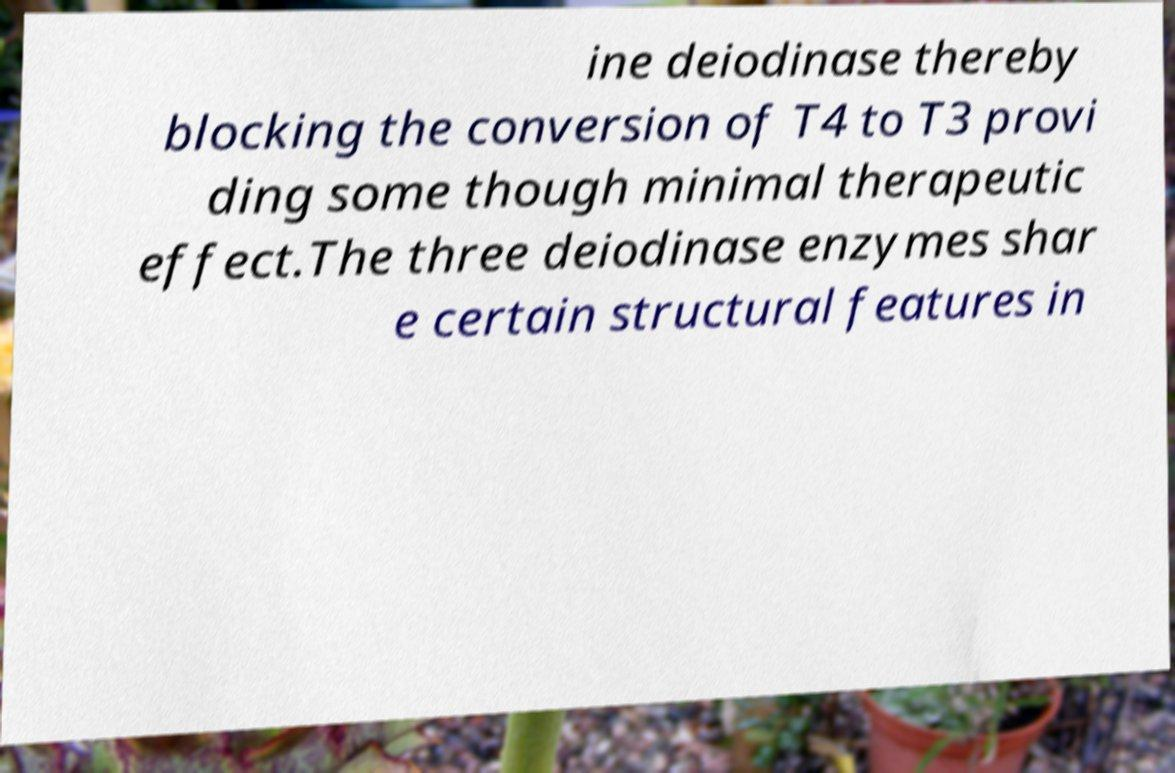Can you accurately transcribe the text from the provided image for me? ine deiodinase thereby blocking the conversion of T4 to T3 provi ding some though minimal therapeutic effect.The three deiodinase enzymes shar e certain structural features in 